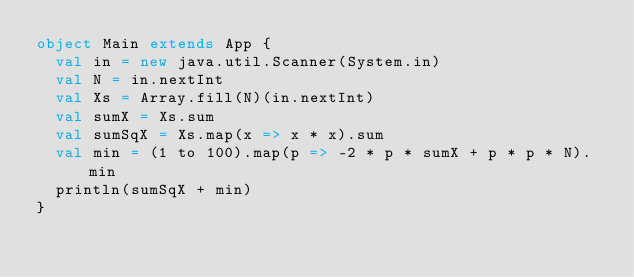<code> <loc_0><loc_0><loc_500><loc_500><_Scala_>object Main extends App {
  val in = new java.util.Scanner(System.in)
  val N = in.nextInt
  val Xs = Array.fill(N)(in.nextInt)
  val sumX = Xs.sum
  val sumSqX = Xs.map(x => x * x).sum
  val min = (1 to 100).map(p => -2 * p * sumX + p * p * N).min
  println(sumSqX + min)
}</code> 